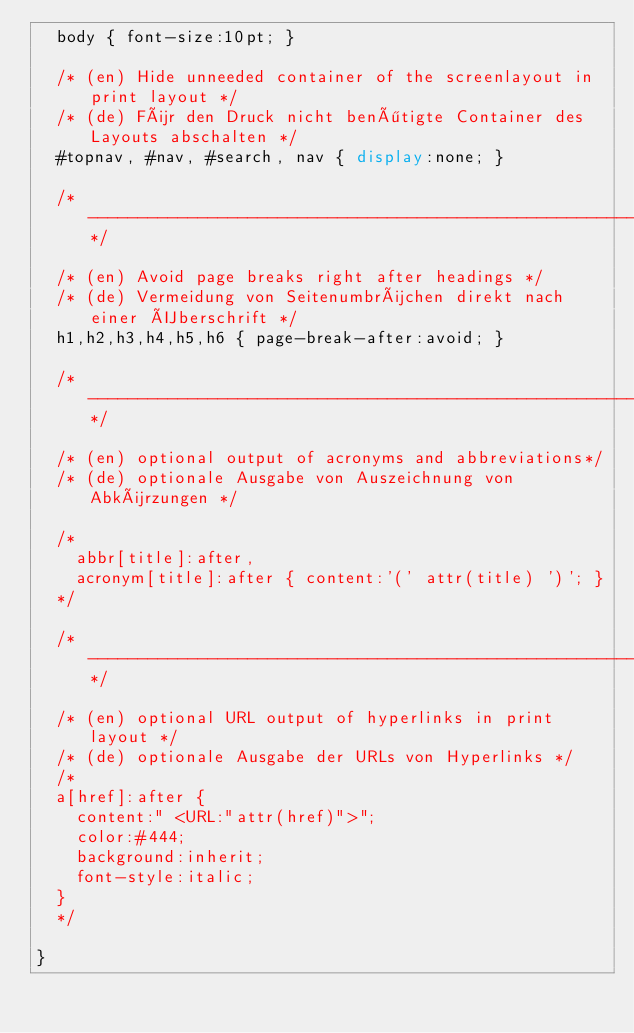<code> <loc_0><loc_0><loc_500><loc_500><_CSS_>  body { font-size:10pt; }

  /* (en) Hide unneeded container of the screenlayout in print layout */
  /* (de) Für den Druck nicht benötigte Container des Layouts abschalten */
  #topnav, #nav, #search, nav { display:none; }

  /*------------------------------------------------------------------------------------------------------*/

  /* (en) Avoid page breaks right after headings */
  /* (de) Vermeidung von Seitenumbrüchen direkt nach einer Überschrift */
  h1,h2,h3,h4,h5,h6 { page-break-after:avoid; }

  /*------------------------------------------------------------------------------------------------------*/

  /* (en) optional output of acronyms and abbreviations*/
  /* (de) optionale Ausgabe von Auszeichnung von Abkürzungen */

  /*
    abbr[title]:after, 
    acronym[title]:after { content:'(' attr(title) ')'; }
  */

  /*------------------------------------------------------------------------------------------------------*/

  /* (en) optional URL output of hyperlinks in print layout */
  /* (de) optionale Ausgabe der URLs von Hyperlinks */
  /*
  a[href]:after {
    content:" <URL:"attr(href)">";
    color:#444;
    background:inherit;
    font-style:italic;
  }
  */

}
</code> 